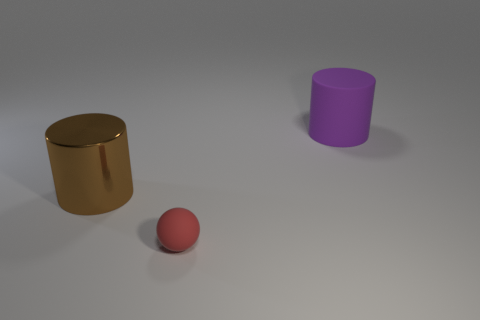How many other objects are there of the same size as the metal object?
Offer a terse response. 1. Does the large thing that is to the left of the big purple thing have the same shape as the big purple matte thing?
Provide a succinct answer. Yes. What color is the other big thing that is the same shape as the brown object?
Make the answer very short. Purple. Is there any other thing that is the same shape as the big metal object?
Offer a terse response. Yes. Are there the same number of large purple matte things that are in front of the matte cylinder and small balls?
Your response must be concise. No. How many matte objects are both behind the big brown metallic thing and in front of the brown cylinder?
Your answer should be compact. 0. What size is the matte object that is the same shape as the brown metal object?
Provide a succinct answer. Large. How many brown things are the same material as the large purple object?
Provide a short and direct response. 0. Are there fewer big metallic things on the right side of the matte cylinder than tiny gray matte spheres?
Give a very brief answer. No. What number of big purple matte objects are there?
Your answer should be compact. 1. 